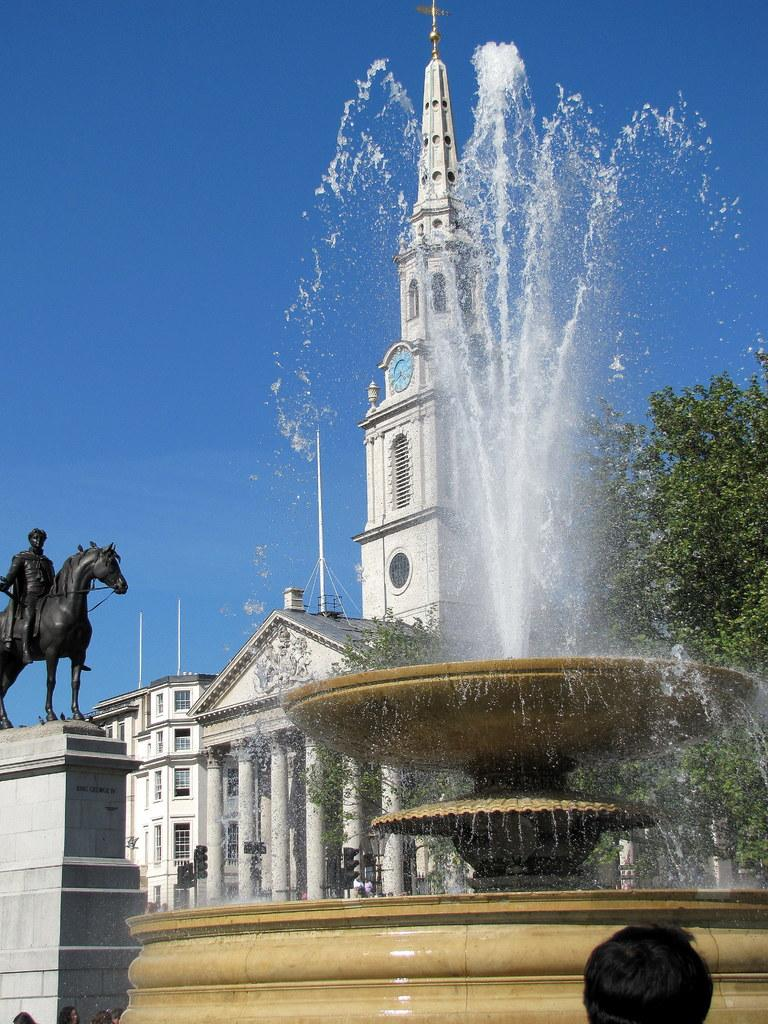What is the main feature in the image? There is a fountain in the image. What other objects or structures can be seen in the image? There is a tree, a building, and a sculpture of a man sitting on a horse in the image. How does the branch of the tree in the image contribute to the earthquake? There is no earthquake present in the image, and the tree does not have a branch in the image. 